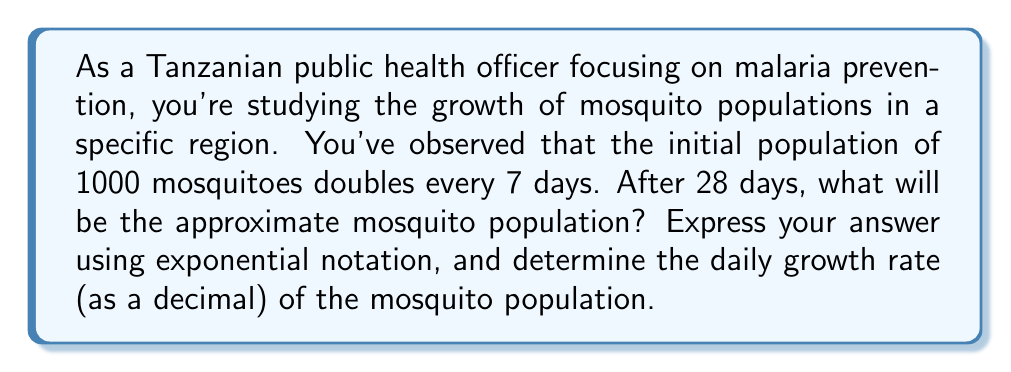Show me your answer to this math problem. Let's approach this problem step-by-step:

1) First, we need to understand the exponential growth formula:
   $$ P(t) = P_0 \cdot (1 + r)^t $$
   where $P(t)$ is the population at time $t$, $P_0$ is the initial population, $r$ is the growth rate, and $t$ is the time.

2) We know that the population doubles every 7 days. This means that after 28 days, the population will have doubled 4 times.
   $$ P(28) = 1000 \cdot 2^4 = 1000 \cdot 16 = 16,000 $$

3) Now, let's find the daily growth rate. We can use the same formula:
   $$ 2 = (1 + r)^7 $$
   where 2 represents doubling, and 7 is the number of days.

4) To solve for $r$, we take the 7th root of both sides:
   $$ \sqrt[7]{2} = 1 + r $$

5) Subtract 1 from both sides:
   $$ \sqrt[7]{2} - 1 = r $$

6) Calculate this value:
   $$ r \approx 1.1040895136738 - 1 = 0.1040895136738 $$

7) This can be rounded to about 0.1041 or 10.41% daily growth rate.
Answer: The mosquito population after 28 days will be approximately 16,000, expressed as $1.6 \times 10^4$ in scientific notation. The daily growth rate of the mosquito population is approximately 0.1041 or 10.41%. 